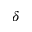<formula> <loc_0><loc_0><loc_500><loc_500>\delta</formula> 